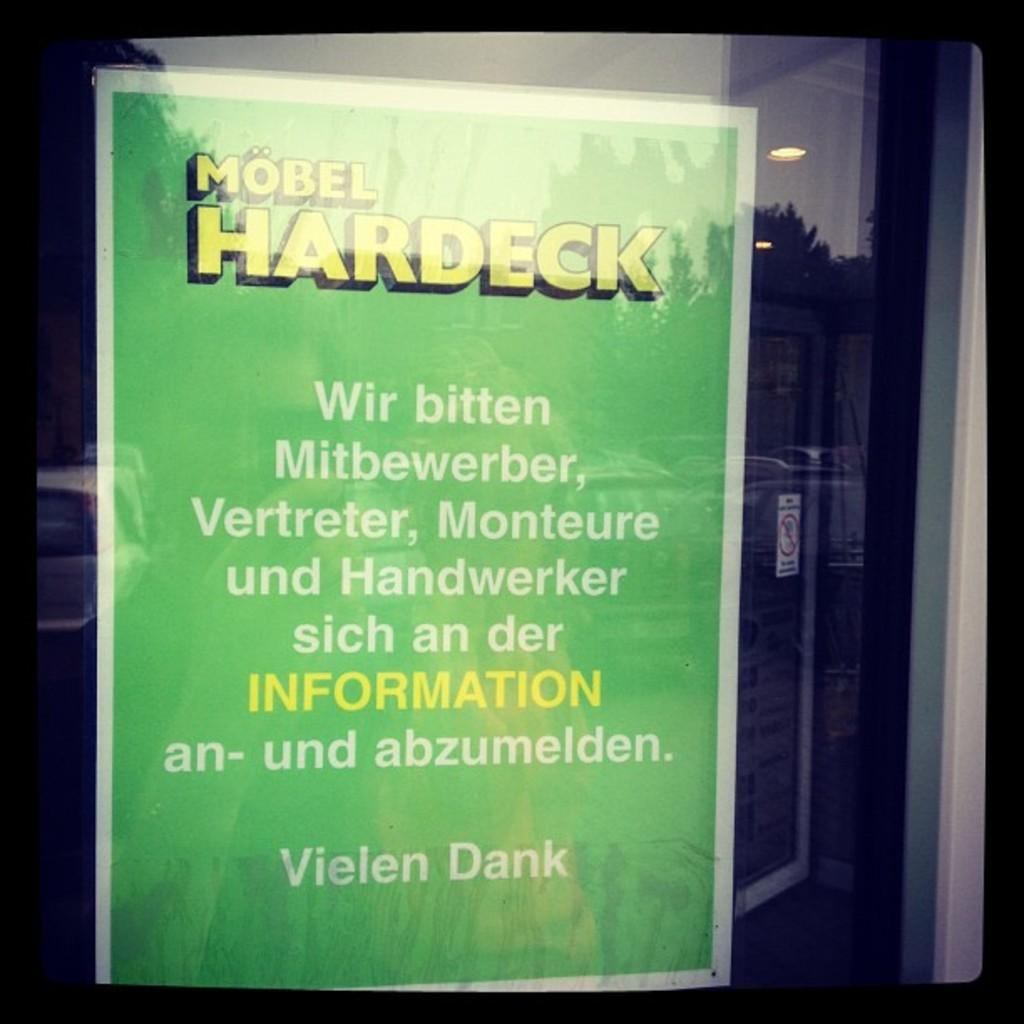<image>
Offer a succinct explanation of the picture presented. Poster sign in Green and white text saying Mobel Hardeck with information in Yellow. 